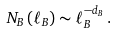<formula> <loc_0><loc_0><loc_500><loc_500>N _ { B } \left ( \ell _ { B } \right ) \sim \ell _ { B } ^ { - d _ { B } } \, .</formula> 